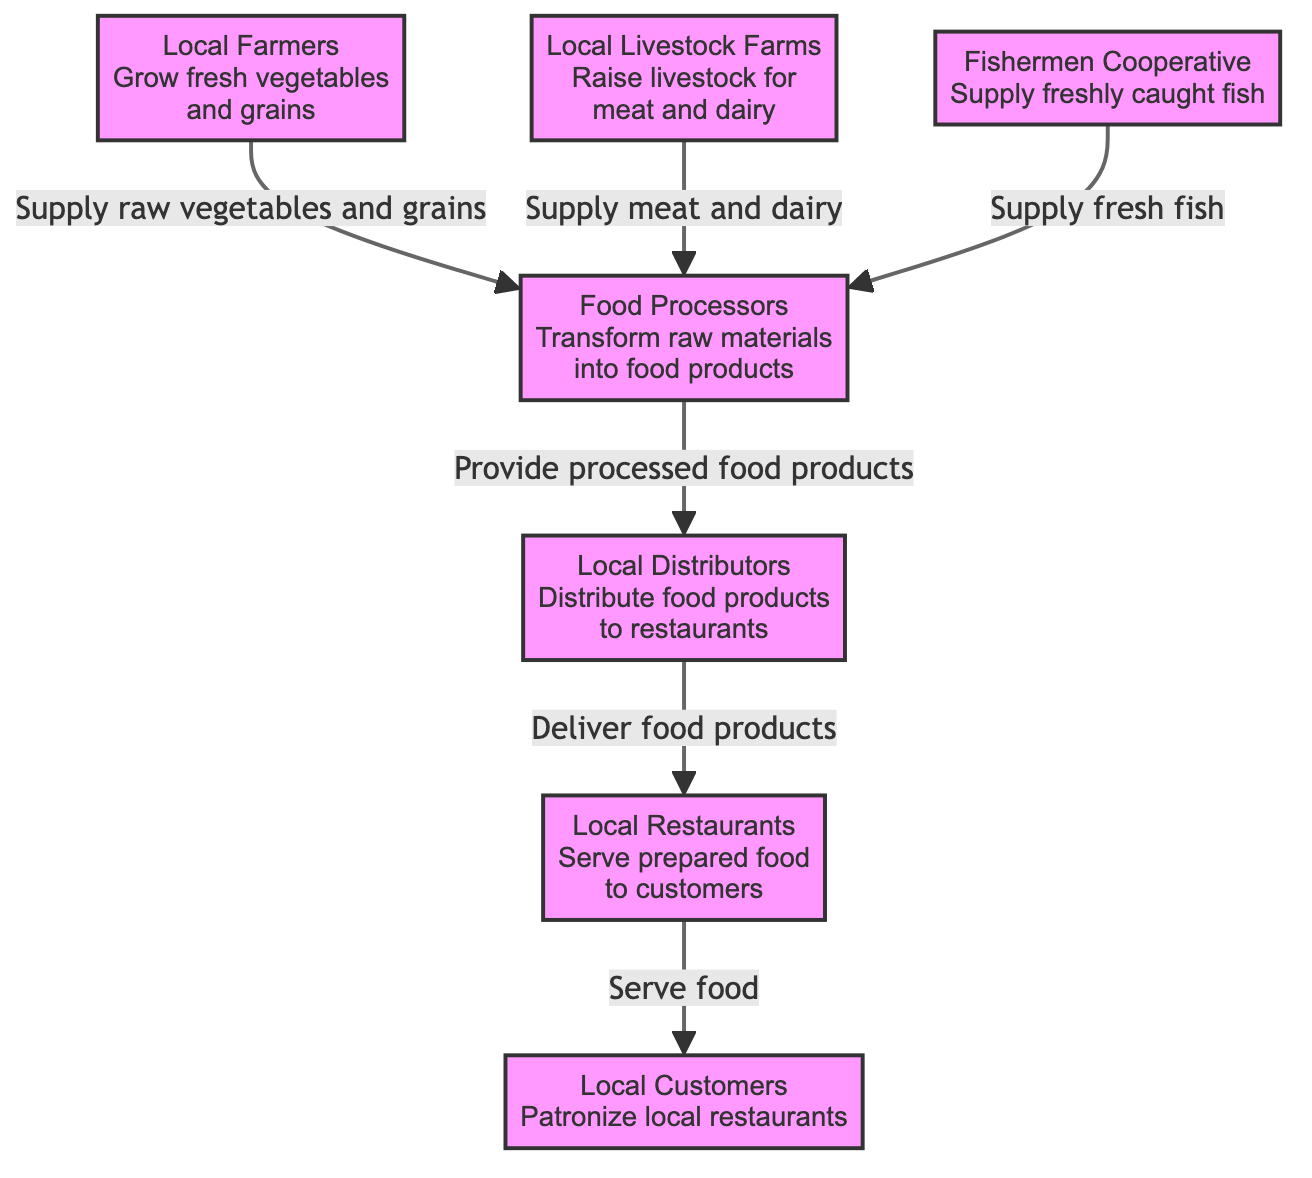What's the role of local farmers in the diagram? Local farmers supply raw vegetables and grains to food processors, which is clearly indicated by the flow leading from the farmers to the food processors in the diagram.
Answer: Supply raw vegetables and grains How many types of suppliers are shown in the diagram? The diagram includes three types of suppliers: local farmers, local livestock farms, and fishermen. These are distinct entities that contribute different food items to the local ecosystem.
Answer: Three Which entity is responsible for distributing food products to restaurants? The local distributors are specifically indicated in the diagram as the entity responsible for delivering food products to restaurants, following the flow from food processors to distributors to restaurants.
Answer: Local distributors What do food processors provide to distributors? Food processors provide processed food products to distributors. This relationship is specified in the flow that connects these two nodes in the diagram.
Answer: Processed food products How do restaurants serve customers? Restaurants serve food to customers, as illustrated by the flow connecting restaurants directly to the local customers in the diagram.
Answer: Serve food What is the connection between livestock farms and food processors? Local livestock farms supply meat and dairy to food processors, which is clearly shown by the arrow linking these two entities in the diagram.
Answer: Supply meat and dairy Which entity does the fishermen cooperative supply? The fishermen cooperative supplies freshly caught fish to food processors, indicated by the direct relationship from fishermen to food processors in the diagram.
Answer: Food processors How do local restaurants impact local customers? Local restaurants impact local customers by serving prepared food, as directly represented in the flow from restaurants to customers in the diagram.
Answer: Serve prepared food 